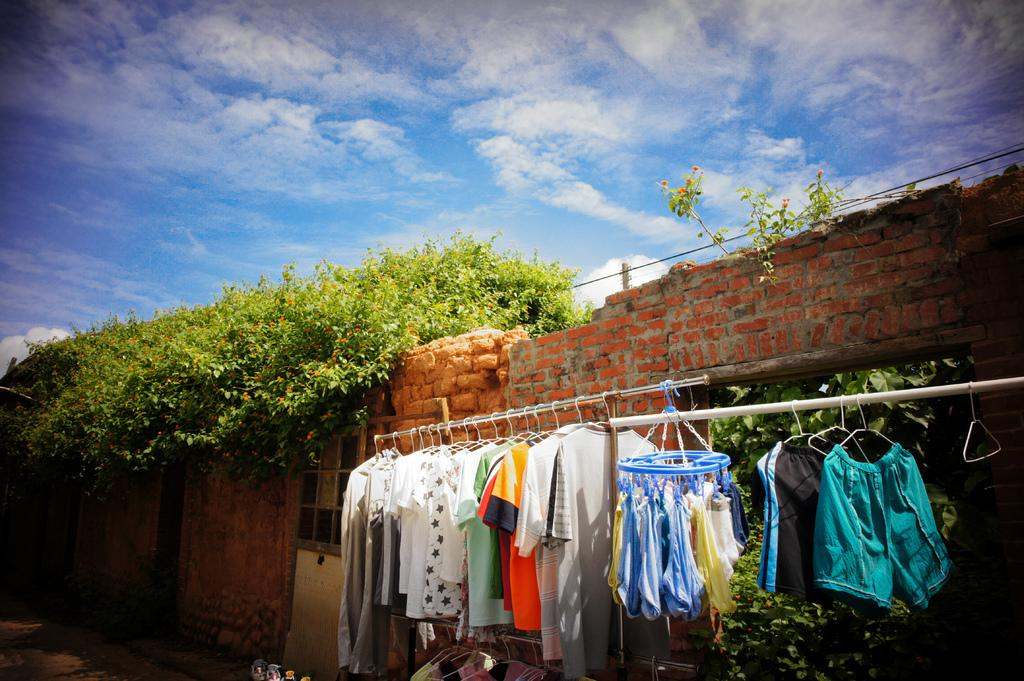What celestial bodies are depicted in the image? There are planets in the image. What is being hung up on metal rods? Clothes are hanging on metal rods. What type of wall can be seen in the image? There is a brick wall in the image. What can be seen in the background of the image? The sky is visible in the background of the image. What type of list can be seen in the image? There is no list present in the image. What is the friction between the planets in the image? The planets in the image are not interacting with each other, so there is no friction between them. 